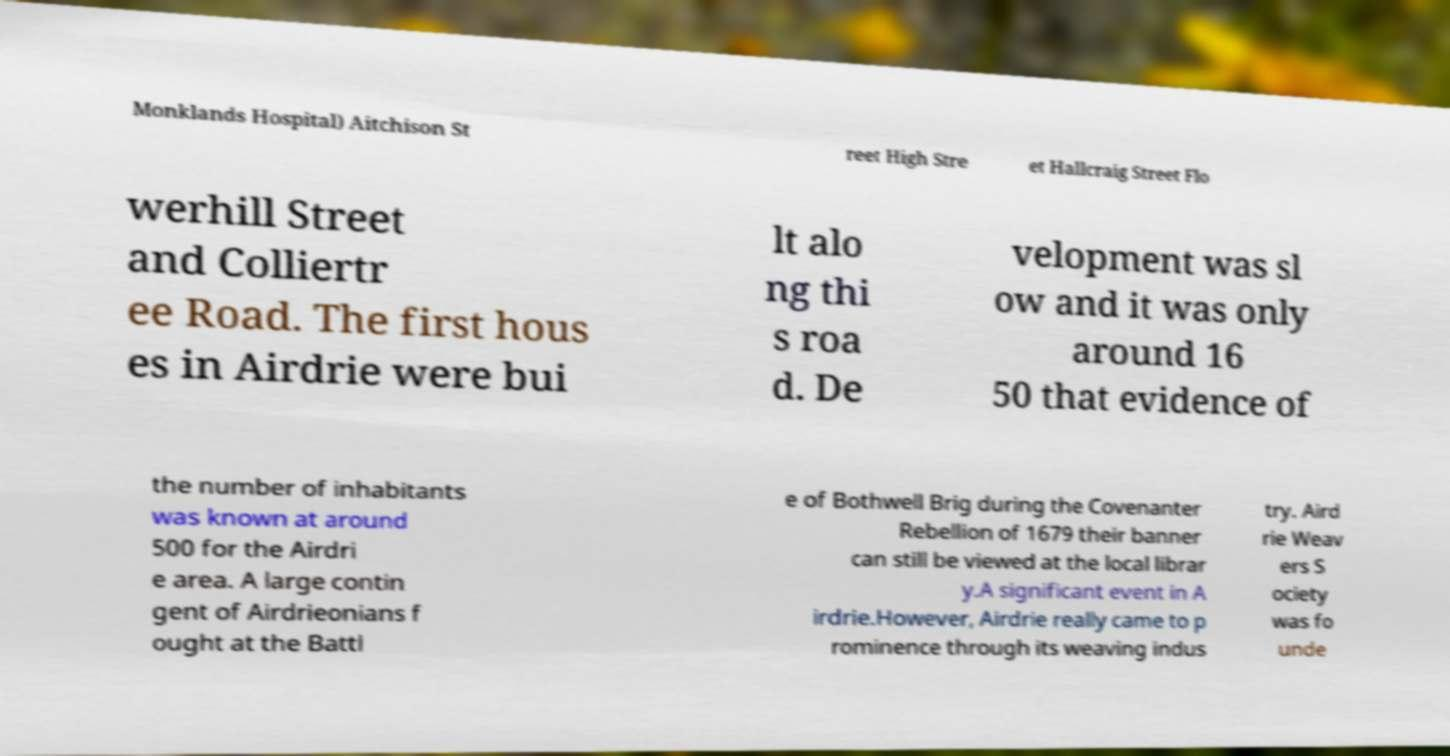For documentation purposes, I need the text within this image transcribed. Could you provide that? Monklands Hospital) Aitchison St reet High Stre et Hallcraig Street Flo werhill Street and Colliertr ee Road. The first hous es in Airdrie were bui lt alo ng thi s roa d. De velopment was sl ow and it was only around 16 50 that evidence of the number of inhabitants was known at around 500 for the Airdri e area. A large contin gent of Airdrieonians f ought at the Battl e of Bothwell Brig during the Covenanter Rebellion of 1679 their banner can still be viewed at the local librar y.A significant event in A irdrie.However, Airdrie really came to p rominence through its weaving indus try. Aird rie Weav ers S ociety was fo unde 